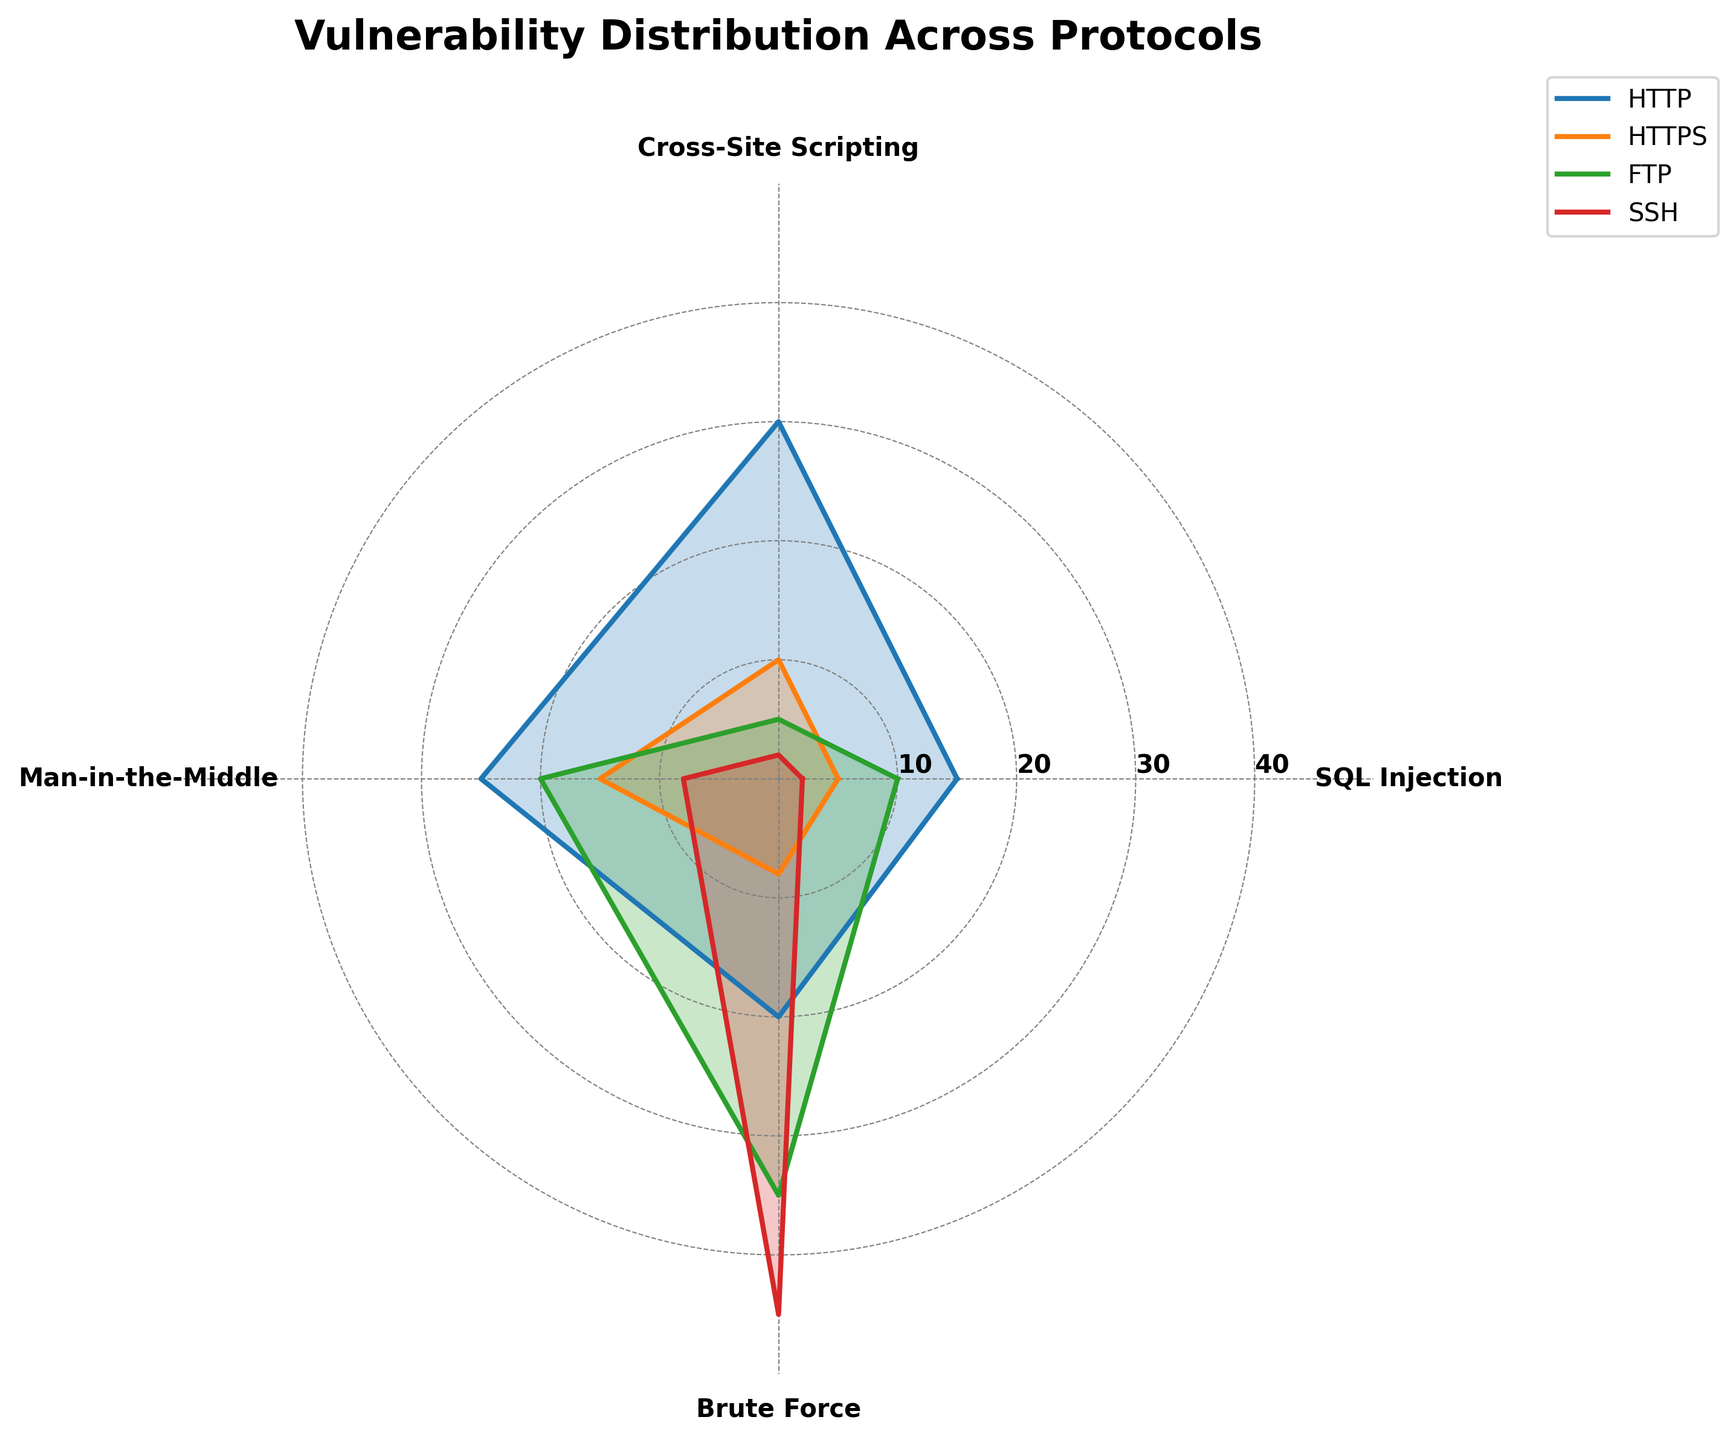What's the title of the figure? The title is usually displayed at the top of the figure. In this case, the title is mentioned in the plotting code under `plt.title`. The title of the figure is "Vulnerability Distribution Across Protocols."
Answer: Vulnerability Distribution Across Protocols How many vulnerability types are analyzed in the figure? The vulnerability types correspond to the different categories analyzed in the radar chart. According to the data provided, there are four categories: SQL Injection, Cross-Site Scripting, Man-in-the-Middle, and Brute Force.
Answer: 4 Which protocol has the highest vulnerability for Brute Force attacks? To find this out, look at the Brute Force axis on the radar chart and identify the protocol with the longest corresponding value. Based on the data, SSH has the highest value for Brute Force attacks (45).
Answer: SSH What is the range of the radial axes? The radial axis range is indicated by the tick marks on the radar chart. Here, the radial ticks are shown at [10, 20, 30, 40] with the range from 0 to 50.
Answer: 0 to 50 Compare the SQL Injection vulnerabilities between HTTP and SSH. Refer to the SQL Injection axis on the radar chart to compare the values for HTTP and SSH. HTTP shows a vulnerability of 15, while SSH shows a vulnerability of 2 for SQL Injection.
Answer: HTTP has more vulnerabilities than SSH Which protocol has the smallest overall vulnerability across all categories? To determine this, consider all the values of each protocol and sum them up: HTTP (15+30+25+20=90), HTTPS (5+10+15+8=38), FTP (10+5+20+35=70), SSH (2+2+8+45=57). HTTPS has the smallest total.
Answer: HTTPS How many protocols are analyzed in the radar chart? The number of protocols can be determined by counting the different labels in the legend. According to the provided data, there are four protocols: HTTP, HTTPS, FTP, and SSH.
Answer: 4 What's the average vulnerability for Cross-Site Scripting across all protocols? To find the average, sum the values for Cross-Site Scripting across all protocols and divide by the number of protocols: (30 + 10 + 5 + 2) / 4 = 47 / 4 = 11.75.
Answer: 11.75 Which vulnerability type shows the smallest difference between the highest and lowest values? Calculate the range for each vulnerability type: SQL Injection (15-2=13), Cross-Site Scripting (30-2=28), Man-in-the-Middle (25-8=17), Brute Force (45-8=37). The smallest difference is in SQL Injection.
Answer: SQL Injection What are the protocols with Man-in-the-Middle vulnerabilities greater than 10? Check the values for Man-in-the-Middle for each protocol: HTTP (25), HTTPS (15), FTP (20), SSH (8). The protocols with values greater than 10 are HTTP, HTTPS, and FTP.
Answer: HTTP, HTTPS, FTP 